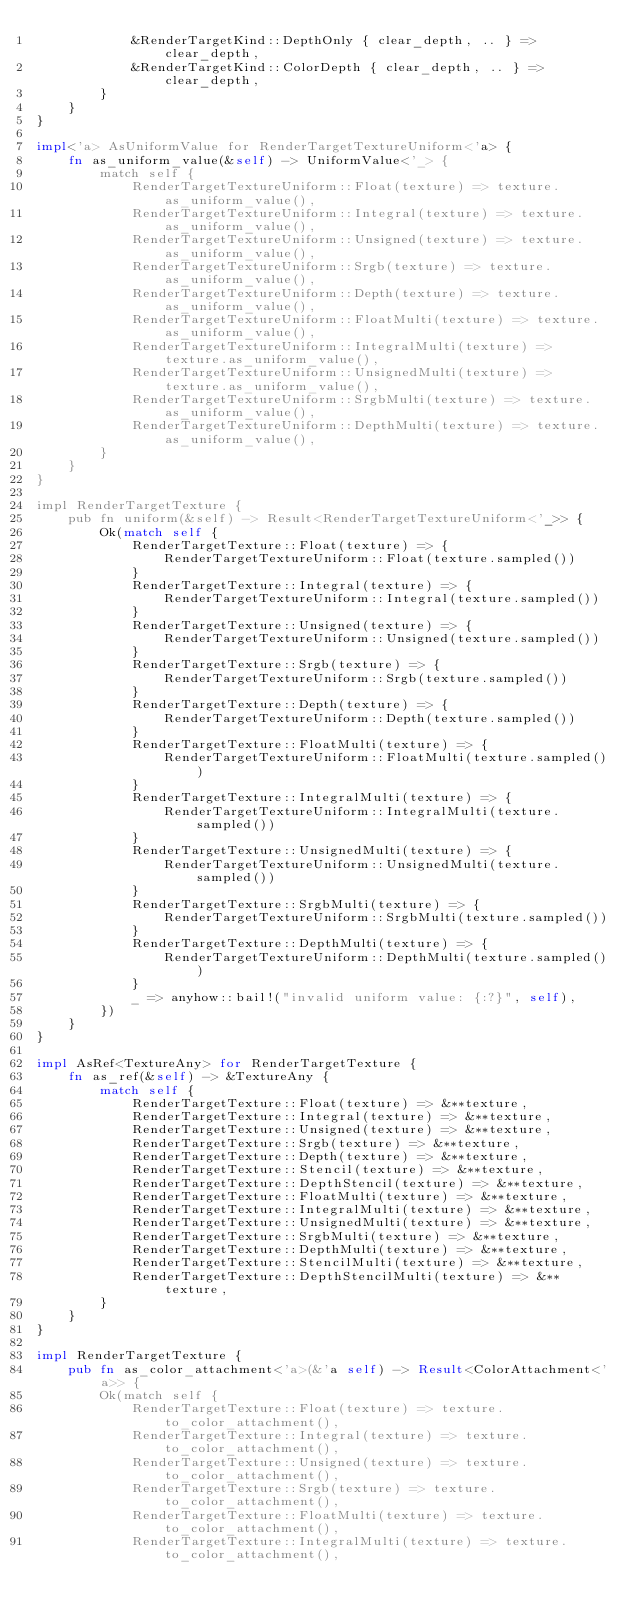<code> <loc_0><loc_0><loc_500><loc_500><_Rust_>            &RenderTargetKind::DepthOnly { clear_depth, .. } => clear_depth,
            &RenderTargetKind::ColorDepth { clear_depth, .. } => clear_depth,
        }
    }
}

impl<'a> AsUniformValue for RenderTargetTextureUniform<'a> {
    fn as_uniform_value(&self) -> UniformValue<'_> {
        match self {
            RenderTargetTextureUniform::Float(texture) => texture.as_uniform_value(),
            RenderTargetTextureUniform::Integral(texture) => texture.as_uniform_value(),
            RenderTargetTextureUniform::Unsigned(texture) => texture.as_uniform_value(),
            RenderTargetTextureUniform::Srgb(texture) => texture.as_uniform_value(),
            RenderTargetTextureUniform::Depth(texture) => texture.as_uniform_value(),
            RenderTargetTextureUniform::FloatMulti(texture) => texture.as_uniform_value(),
            RenderTargetTextureUniform::IntegralMulti(texture) => texture.as_uniform_value(),
            RenderTargetTextureUniform::UnsignedMulti(texture) => texture.as_uniform_value(),
            RenderTargetTextureUniform::SrgbMulti(texture) => texture.as_uniform_value(),
            RenderTargetTextureUniform::DepthMulti(texture) => texture.as_uniform_value(),
        }
    }
}

impl RenderTargetTexture {
    pub fn uniform(&self) -> Result<RenderTargetTextureUniform<'_>> {
        Ok(match self {
            RenderTargetTexture::Float(texture) => {
                RenderTargetTextureUniform::Float(texture.sampled())
            }
            RenderTargetTexture::Integral(texture) => {
                RenderTargetTextureUniform::Integral(texture.sampled())
            }
            RenderTargetTexture::Unsigned(texture) => {
                RenderTargetTextureUniform::Unsigned(texture.sampled())
            }
            RenderTargetTexture::Srgb(texture) => {
                RenderTargetTextureUniform::Srgb(texture.sampled())
            }
            RenderTargetTexture::Depth(texture) => {
                RenderTargetTextureUniform::Depth(texture.sampled())
            }
            RenderTargetTexture::FloatMulti(texture) => {
                RenderTargetTextureUniform::FloatMulti(texture.sampled())
            }
            RenderTargetTexture::IntegralMulti(texture) => {
                RenderTargetTextureUniform::IntegralMulti(texture.sampled())
            }
            RenderTargetTexture::UnsignedMulti(texture) => {
                RenderTargetTextureUniform::UnsignedMulti(texture.sampled())
            }
            RenderTargetTexture::SrgbMulti(texture) => {
                RenderTargetTextureUniform::SrgbMulti(texture.sampled())
            }
            RenderTargetTexture::DepthMulti(texture) => {
                RenderTargetTextureUniform::DepthMulti(texture.sampled())
            }
            _ => anyhow::bail!("invalid uniform value: {:?}", self),
        })
    }
}

impl AsRef<TextureAny> for RenderTargetTexture {
    fn as_ref(&self) -> &TextureAny {
        match self {
            RenderTargetTexture::Float(texture) => &**texture,
            RenderTargetTexture::Integral(texture) => &**texture,
            RenderTargetTexture::Unsigned(texture) => &**texture,
            RenderTargetTexture::Srgb(texture) => &**texture,
            RenderTargetTexture::Depth(texture) => &**texture,
            RenderTargetTexture::Stencil(texture) => &**texture,
            RenderTargetTexture::DepthStencil(texture) => &**texture,
            RenderTargetTexture::FloatMulti(texture) => &**texture,
            RenderTargetTexture::IntegralMulti(texture) => &**texture,
            RenderTargetTexture::UnsignedMulti(texture) => &**texture,
            RenderTargetTexture::SrgbMulti(texture) => &**texture,
            RenderTargetTexture::DepthMulti(texture) => &**texture,
            RenderTargetTexture::StencilMulti(texture) => &**texture,
            RenderTargetTexture::DepthStencilMulti(texture) => &**texture,
        }
    }
}

impl RenderTargetTexture {
    pub fn as_color_attachment<'a>(&'a self) -> Result<ColorAttachment<'a>> {
        Ok(match self {
            RenderTargetTexture::Float(texture) => texture.to_color_attachment(),
            RenderTargetTexture::Integral(texture) => texture.to_color_attachment(),
            RenderTargetTexture::Unsigned(texture) => texture.to_color_attachment(),
            RenderTargetTexture::Srgb(texture) => texture.to_color_attachment(),
            RenderTargetTexture::FloatMulti(texture) => texture.to_color_attachment(),
            RenderTargetTexture::IntegralMulti(texture) => texture.to_color_attachment(),</code> 